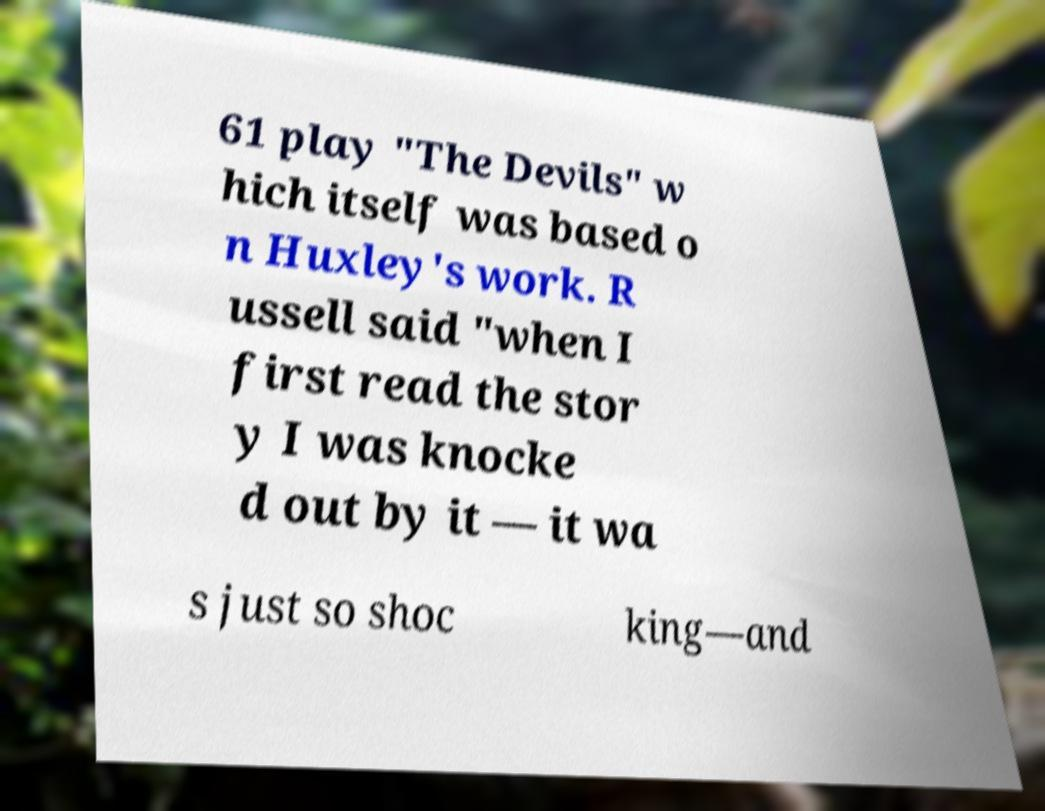For documentation purposes, I need the text within this image transcribed. Could you provide that? 61 play "The Devils" w hich itself was based o n Huxley's work. R ussell said "when I first read the stor y I was knocke d out by it — it wa s just so shoc king—and 